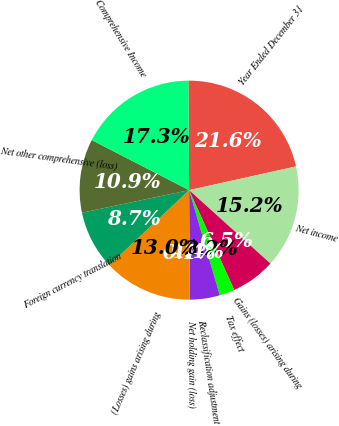<chart> <loc_0><loc_0><loc_500><loc_500><pie_chart><fcel>Year Ended December 31<fcel>Net income<fcel>Gains (losses) arising during<fcel>Tax effect<fcel>Reclassification adjustment<fcel>Net holding gain (loss)<fcel>(Losses) gains arising during<fcel>Foreign currency translation<fcel>Net other comprehensive (loss)<fcel>Comprehensive Income<nl><fcel>21.63%<fcel>15.17%<fcel>6.55%<fcel>2.24%<fcel>4.4%<fcel>0.09%<fcel>13.02%<fcel>8.71%<fcel>10.86%<fcel>17.33%<nl></chart> 